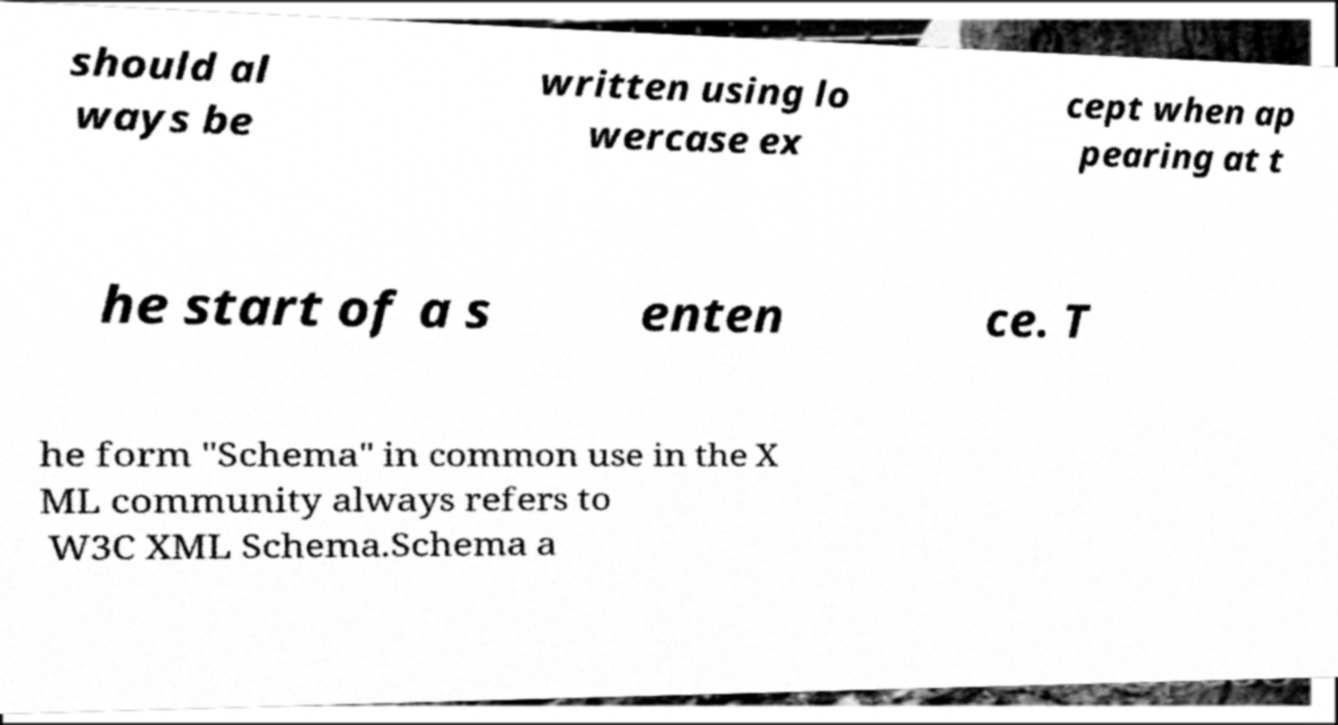What messages or text are displayed in this image? I need them in a readable, typed format. should al ways be written using lo wercase ex cept when ap pearing at t he start of a s enten ce. T he form "Schema" in common use in the X ML community always refers to W3C XML Schema.Schema a 